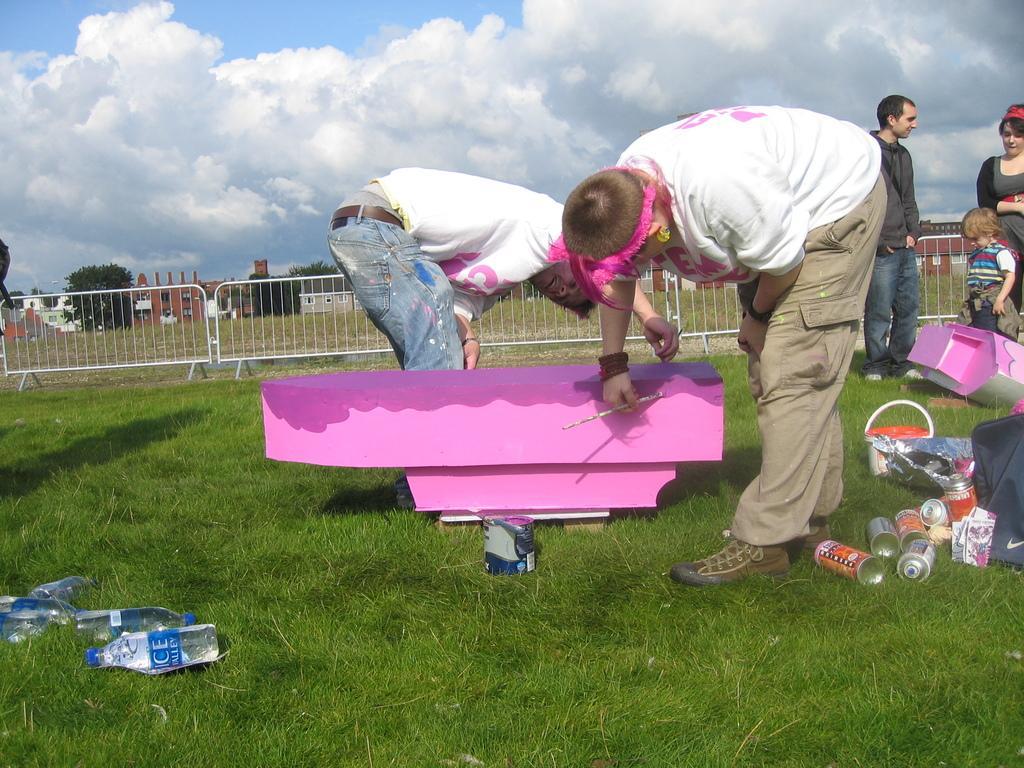Please provide a concise description of this image. This is an outside view. In the middle of the image there are two persons bending, holding brushes in the hands and painting to an object. On the right side a man, a woman and a baby are standing. Here I can see few bottles, bags and some other objects placed on the ground. On the left side there are few bottles. At the back of these people there is a railing. In the background there are many trees and buildings. At the top of the image I can see the sky and clouds. At the bottom, I can see the grass on the ground. 